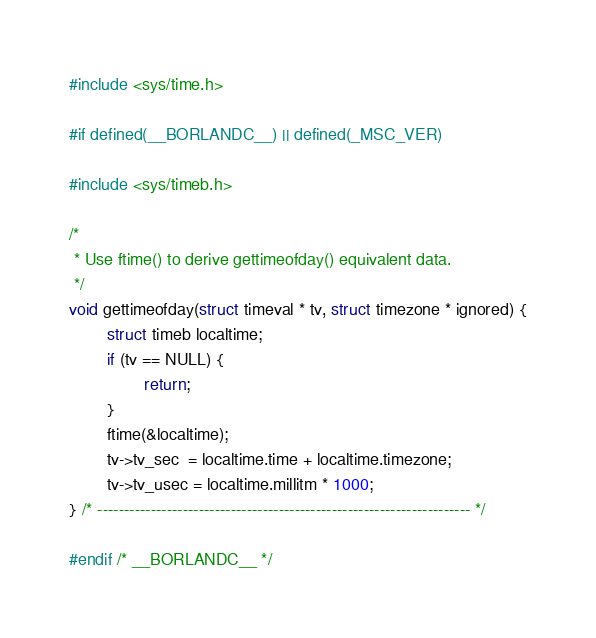<code> <loc_0><loc_0><loc_500><loc_500><_C_>#include <sys/time.h>

#if defined(__BORLANDC__) || defined(_MSC_VER)

#include <sys/timeb.h>

/*
 * Use ftime() to derive gettimeofday() equivalent data.
 */
void gettimeofday(struct timeval * tv, struct timezone * ignored) {
        struct timeb localtime;
        if (tv == NULL) {
                return;
        }
        ftime(&localtime);
        tv->tv_sec  = localtime.time + localtime.timezone;
        tv->tv_usec = localtime.millitm * 1000;
} /* ---------------------------------------------------------------------- */

#endif /* __BORLANDC__ */
</code> 